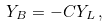<formula> <loc_0><loc_0><loc_500><loc_500>Y _ { B } = - C Y _ { L } \, ,</formula> 